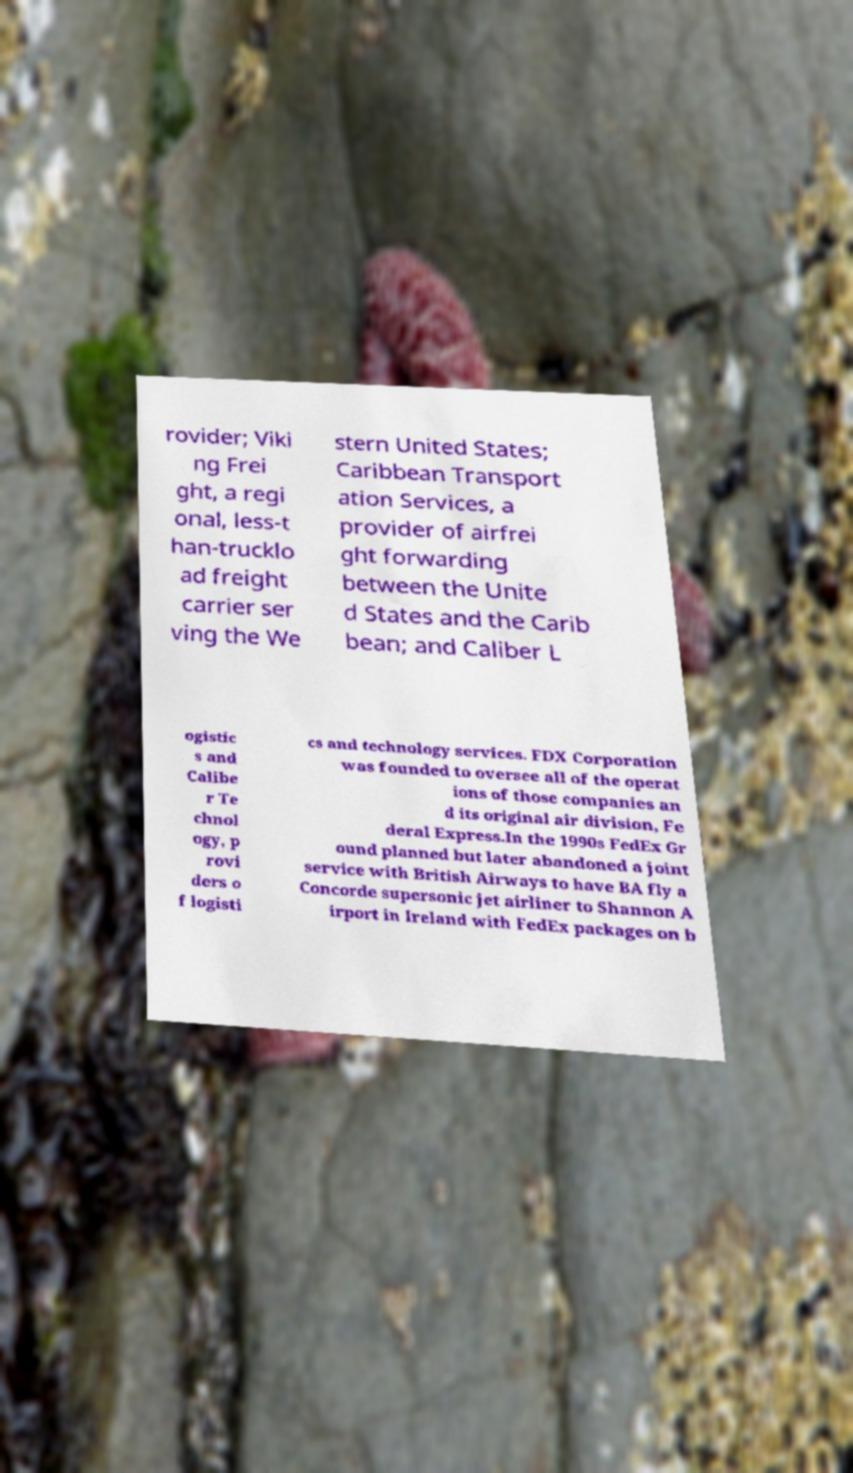I need the written content from this picture converted into text. Can you do that? rovider; Viki ng Frei ght, a regi onal, less-t han-trucklo ad freight carrier ser ving the We stern United States; Caribbean Transport ation Services, a provider of airfrei ght forwarding between the Unite d States and the Carib bean; and Caliber L ogistic s and Calibe r Te chnol ogy, p rovi ders o f logisti cs and technology services. FDX Corporation was founded to oversee all of the operat ions of those companies an d its original air division, Fe deral Express.In the 1990s FedEx Gr ound planned but later abandoned a joint service with British Airways to have BA fly a Concorde supersonic jet airliner to Shannon A irport in Ireland with FedEx packages on b 